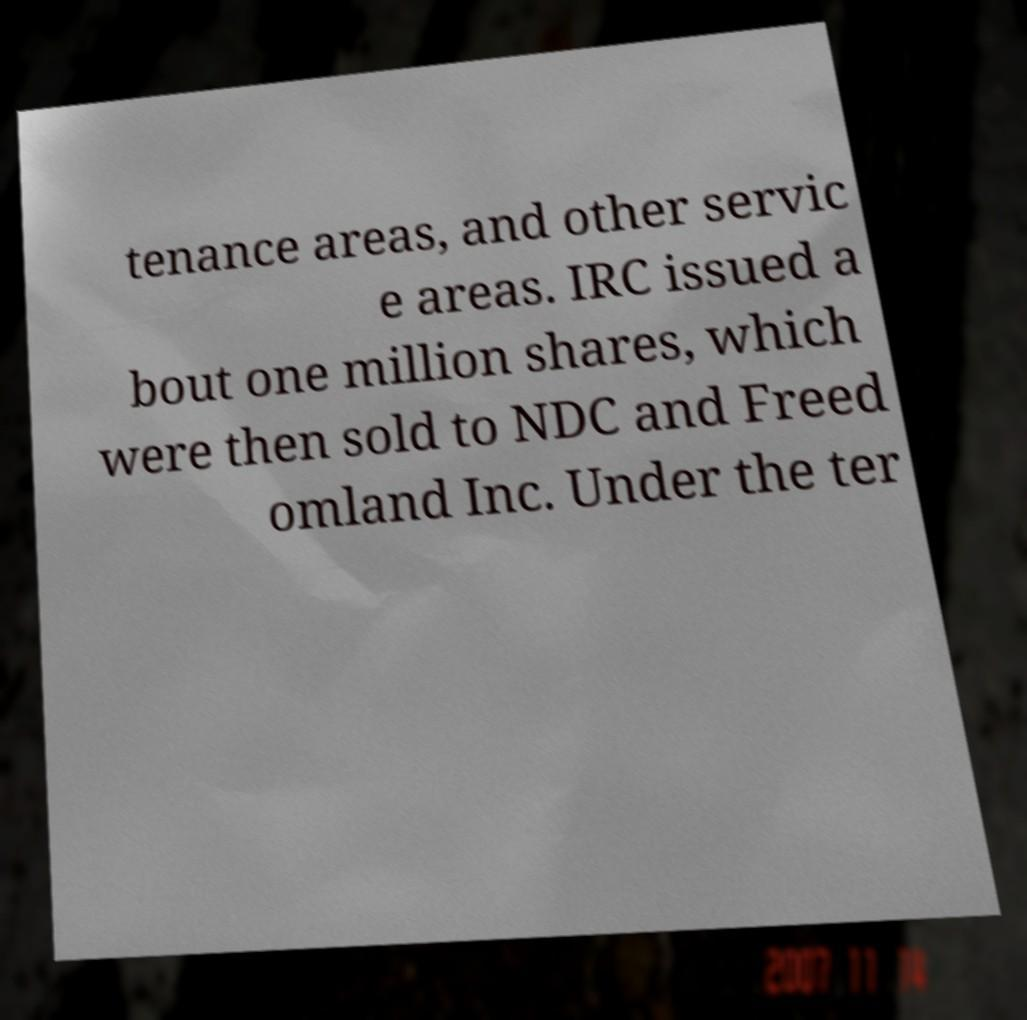I need the written content from this picture converted into text. Can you do that? tenance areas, and other servic e areas. IRC issued a bout one million shares, which were then sold to NDC and Freed omland Inc. Under the ter 